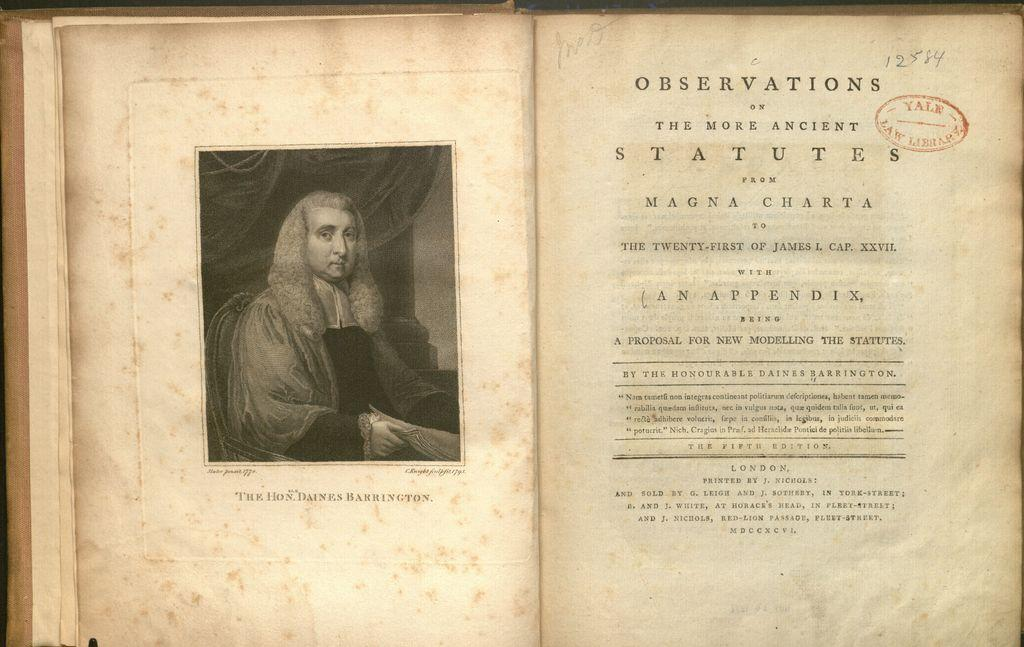<image>
Describe the image concisely. A page in a book about observations of ancient statutes has been hand-marked as 12584 by someone. 